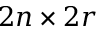<formula> <loc_0><loc_0><loc_500><loc_500>2 n \times 2 r</formula> 